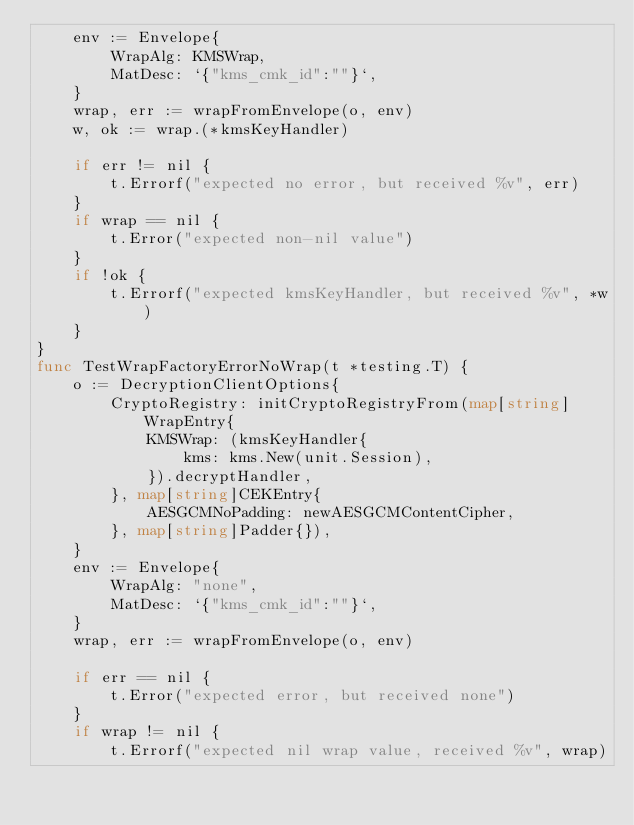Convert code to text. <code><loc_0><loc_0><loc_500><loc_500><_Go_>	env := Envelope{
		WrapAlg: KMSWrap,
		MatDesc: `{"kms_cmk_id":""}`,
	}
	wrap, err := wrapFromEnvelope(o, env)
	w, ok := wrap.(*kmsKeyHandler)

	if err != nil {
		t.Errorf("expected no error, but received %v", err)
	}
	if wrap == nil {
		t.Error("expected non-nil value")
	}
	if !ok {
		t.Errorf("expected kmsKeyHandler, but received %v", *w)
	}
}
func TestWrapFactoryErrorNoWrap(t *testing.T) {
	o := DecryptionClientOptions{
		CryptoRegistry: initCryptoRegistryFrom(map[string]WrapEntry{
			KMSWrap: (kmsKeyHandler{
				kms: kms.New(unit.Session),
			}).decryptHandler,
		}, map[string]CEKEntry{
			AESGCMNoPadding: newAESGCMContentCipher,
		}, map[string]Padder{}),
	}
	env := Envelope{
		WrapAlg: "none",
		MatDesc: `{"kms_cmk_id":""}`,
	}
	wrap, err := wrapFromEnvelope(o, env)

	if err == nil {
		t.Error("expected error, but received none")
	}
	if wrap != nil {
		t.Errorf("expected nil wrap value, received %v", wrap)</code> 